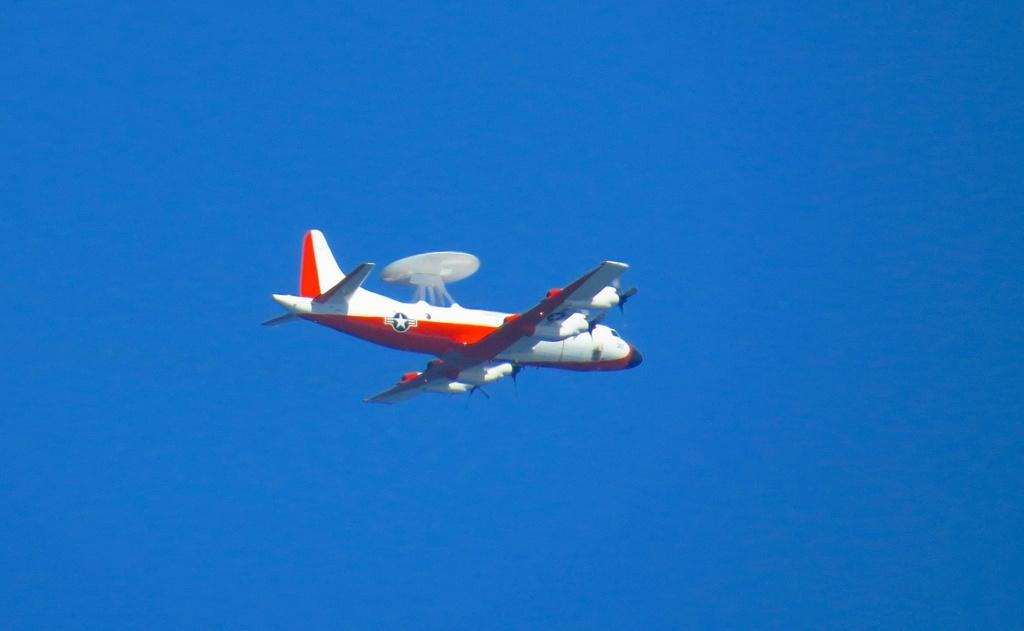What is the main subject of the picture? The main subject of the picture is a plane. What is the plane doing in the image? The plane is flying in the air. What can be seen in the background of the image? There is a sky visible in the background of the image. How does the plane contribute to the health of the passengers in the image? The image does not provide information about the passengers or their health, so it cannot be determined from the image. 